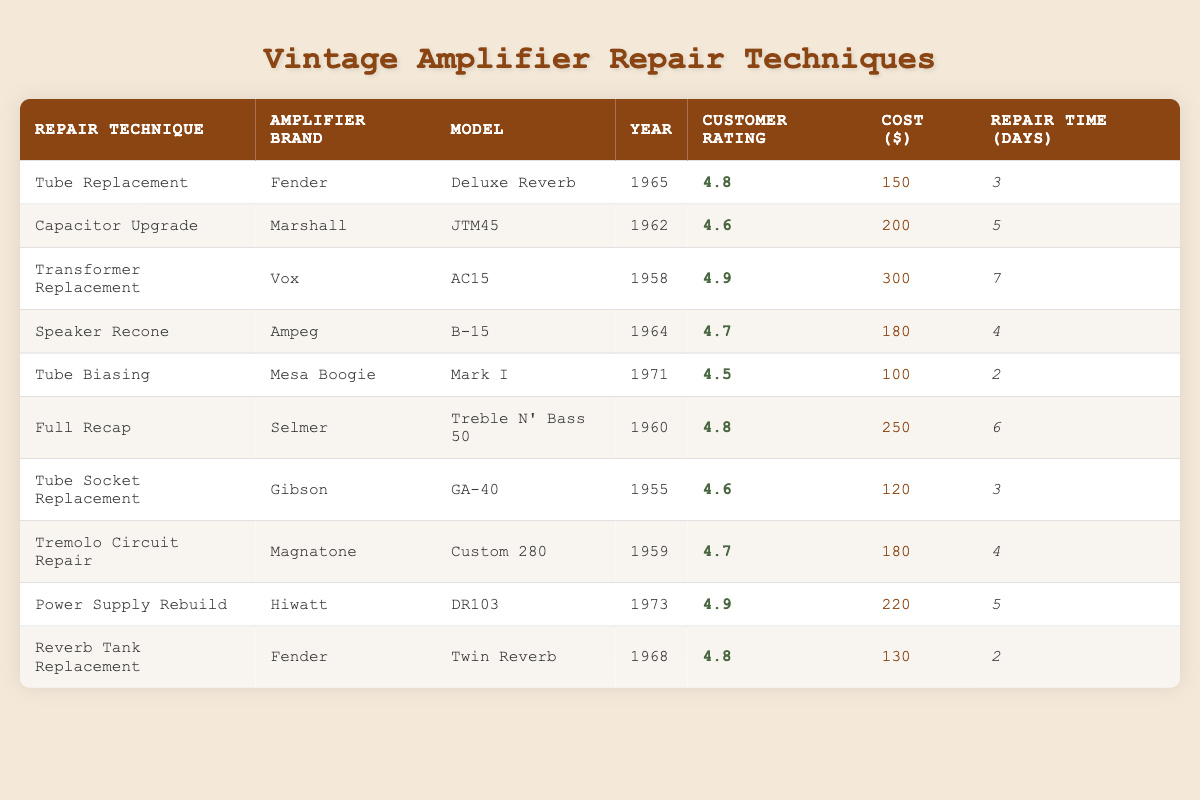What is the customer rating for the Transformer Replacement technique? The table indicates that the Transformer Replacement technique corresponds to a customer rating of 4.9.
Answer: 4.9 Which amplifier brand had the highest customer rating? By comparing the customer ratings, Vox with the Transformer Replacement technique has the highest rating of 4.9.
Answer: Vox How many days does it take on average to repair amplifiers using Tube Replacement and Tube Biasing techniques? The repair time for Tube Replacement is 3 days and for Tube Biasing is 2 days. The average is (3 + 2) / 2 = 2.5 days.
Answer: 2.5 days Is the cost of the Full Recap repair technique higher than the Speaker Recone? Full Recap costs 250, while Speaker Recone costs 180; hence, Full Recap is indeed higher.
Answer: Yes What is the total cost of all repair techniques listed? Summing up the costs: 150 (Tube Replacement) + 200 (Capacitor Upgrade) + 300 (Transformer Replacement) + 180 (Speaker Recone) + 100 (Tube Biasing) + 250 (Full Recap) + 120 (Tube Socket Replacement) + 180 (Tremolo Circuit Repair) + 220 (Power Supply Rebuild) + 130 (Reverb Tank Replacement) equals 1,780.
Answer: 1780 How many different amplifier brands are represented in the table? The brands listed are Fender, Marshall, Vox, Ampeg, Mesa Boogie, Selmer, Gibson, Magnatone, and Hiwatt, totaling 9 unique brands.
Answer: 9 Which repair technique has the shortest repair time? The Tube Biasing technique takes only 2 days, the shortest among all repair techniques listed in the table.
Answer: Tube Biasing Are there any amplifier repair techniques with a rating of 4.8? Yes, there are three repair techniques with a rating of 4.8: Tube Replacement, Full Recap, and Reverb Tank Replacement.
Answer: Yes What is the difference in customer rating between the Transformer Replacement and the Tube Biasing techniques? Transformer Replacement has a rating of 4.9, while Tube Biasing has a rating of 4.5. The difference is 4.9 - 4.5 = 0.4.
Answer: 0.4 